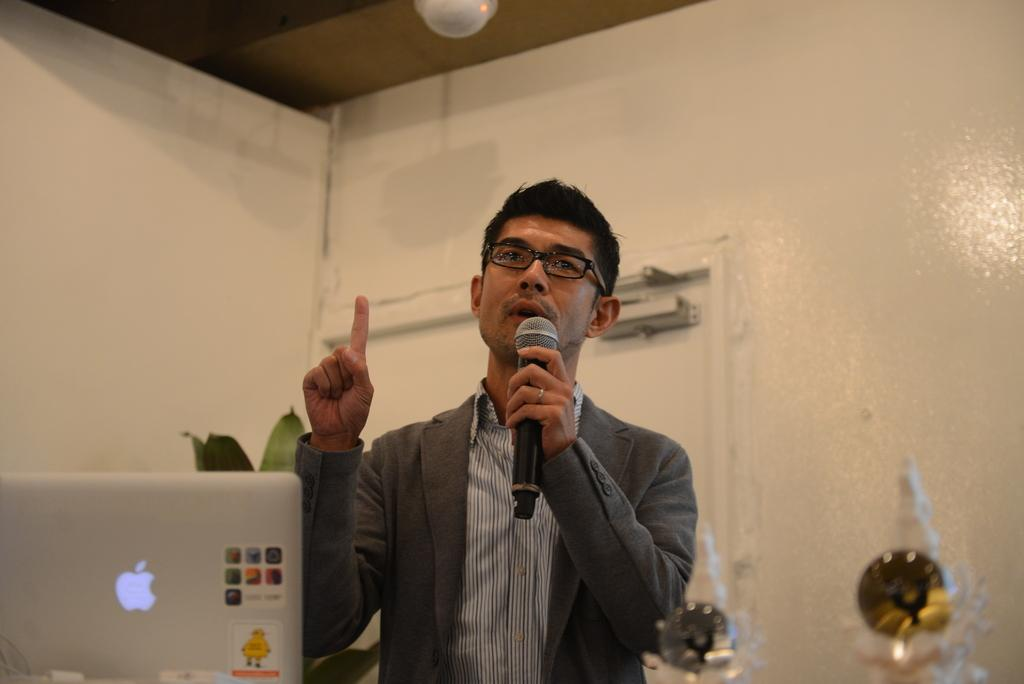Who is the person in the image? There is a man in the image. What is the man wearing? The man is wearing a suit. What is the man holding in the image? The man is holding a microphone. What other object can be seen in the image? There is a laptop in the image. What is happening in the background of the image? There is a plant in the background of the image. What is the man doing with the microphone? The man is talking in front of the microphone. What type of wool is the man wearing in the image? The man is not wearing wool in the image; he is wearing a suit. Can you see a mailbox in the image? There is no mailbox present in the image. 